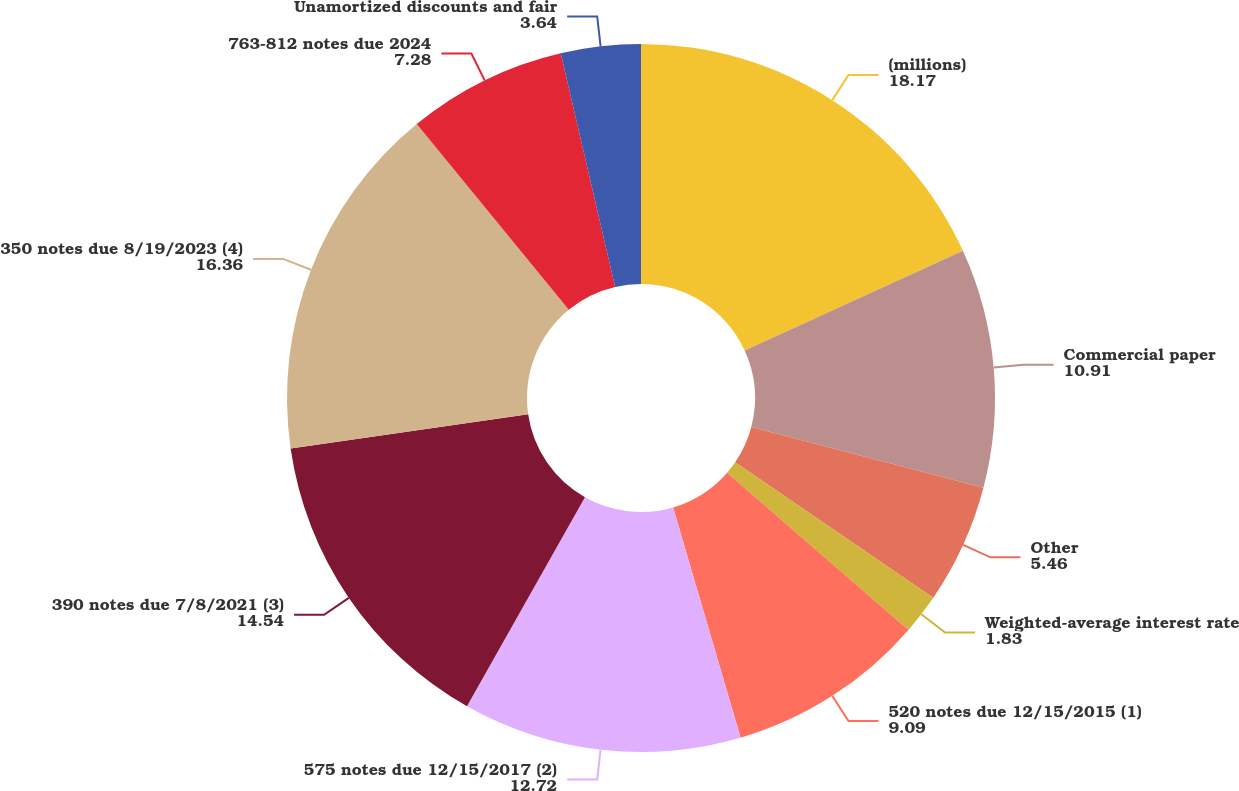Convert chart to OTSL. <chart><loc_0><loc_0><loc_500><loc_500><pie_chart><fcel>(millions)<fcel>Commercial paper<fcel>Other<fcel>Weighted-average interest rate<fcel>520 notes due 12/15/2015 (1)<fcel>575 notes due 12/15/2017 (2)<fcel>390 notes due 7/8/2021 (3)<fcel>350 notes due 8/19/2023 (4)<fcel>763-812 notes due 2024<fcel>Unamortized discounts and fair<nl><fcel>18.17%<fcel>10.91%<fcel>5.46%<fcel>1.83%<fcel>9.09%<fcel>12.72%<fcel>14.54%<fcel>16.36%<fcel>7.28%<fcel>3.64%<nl></chart> 